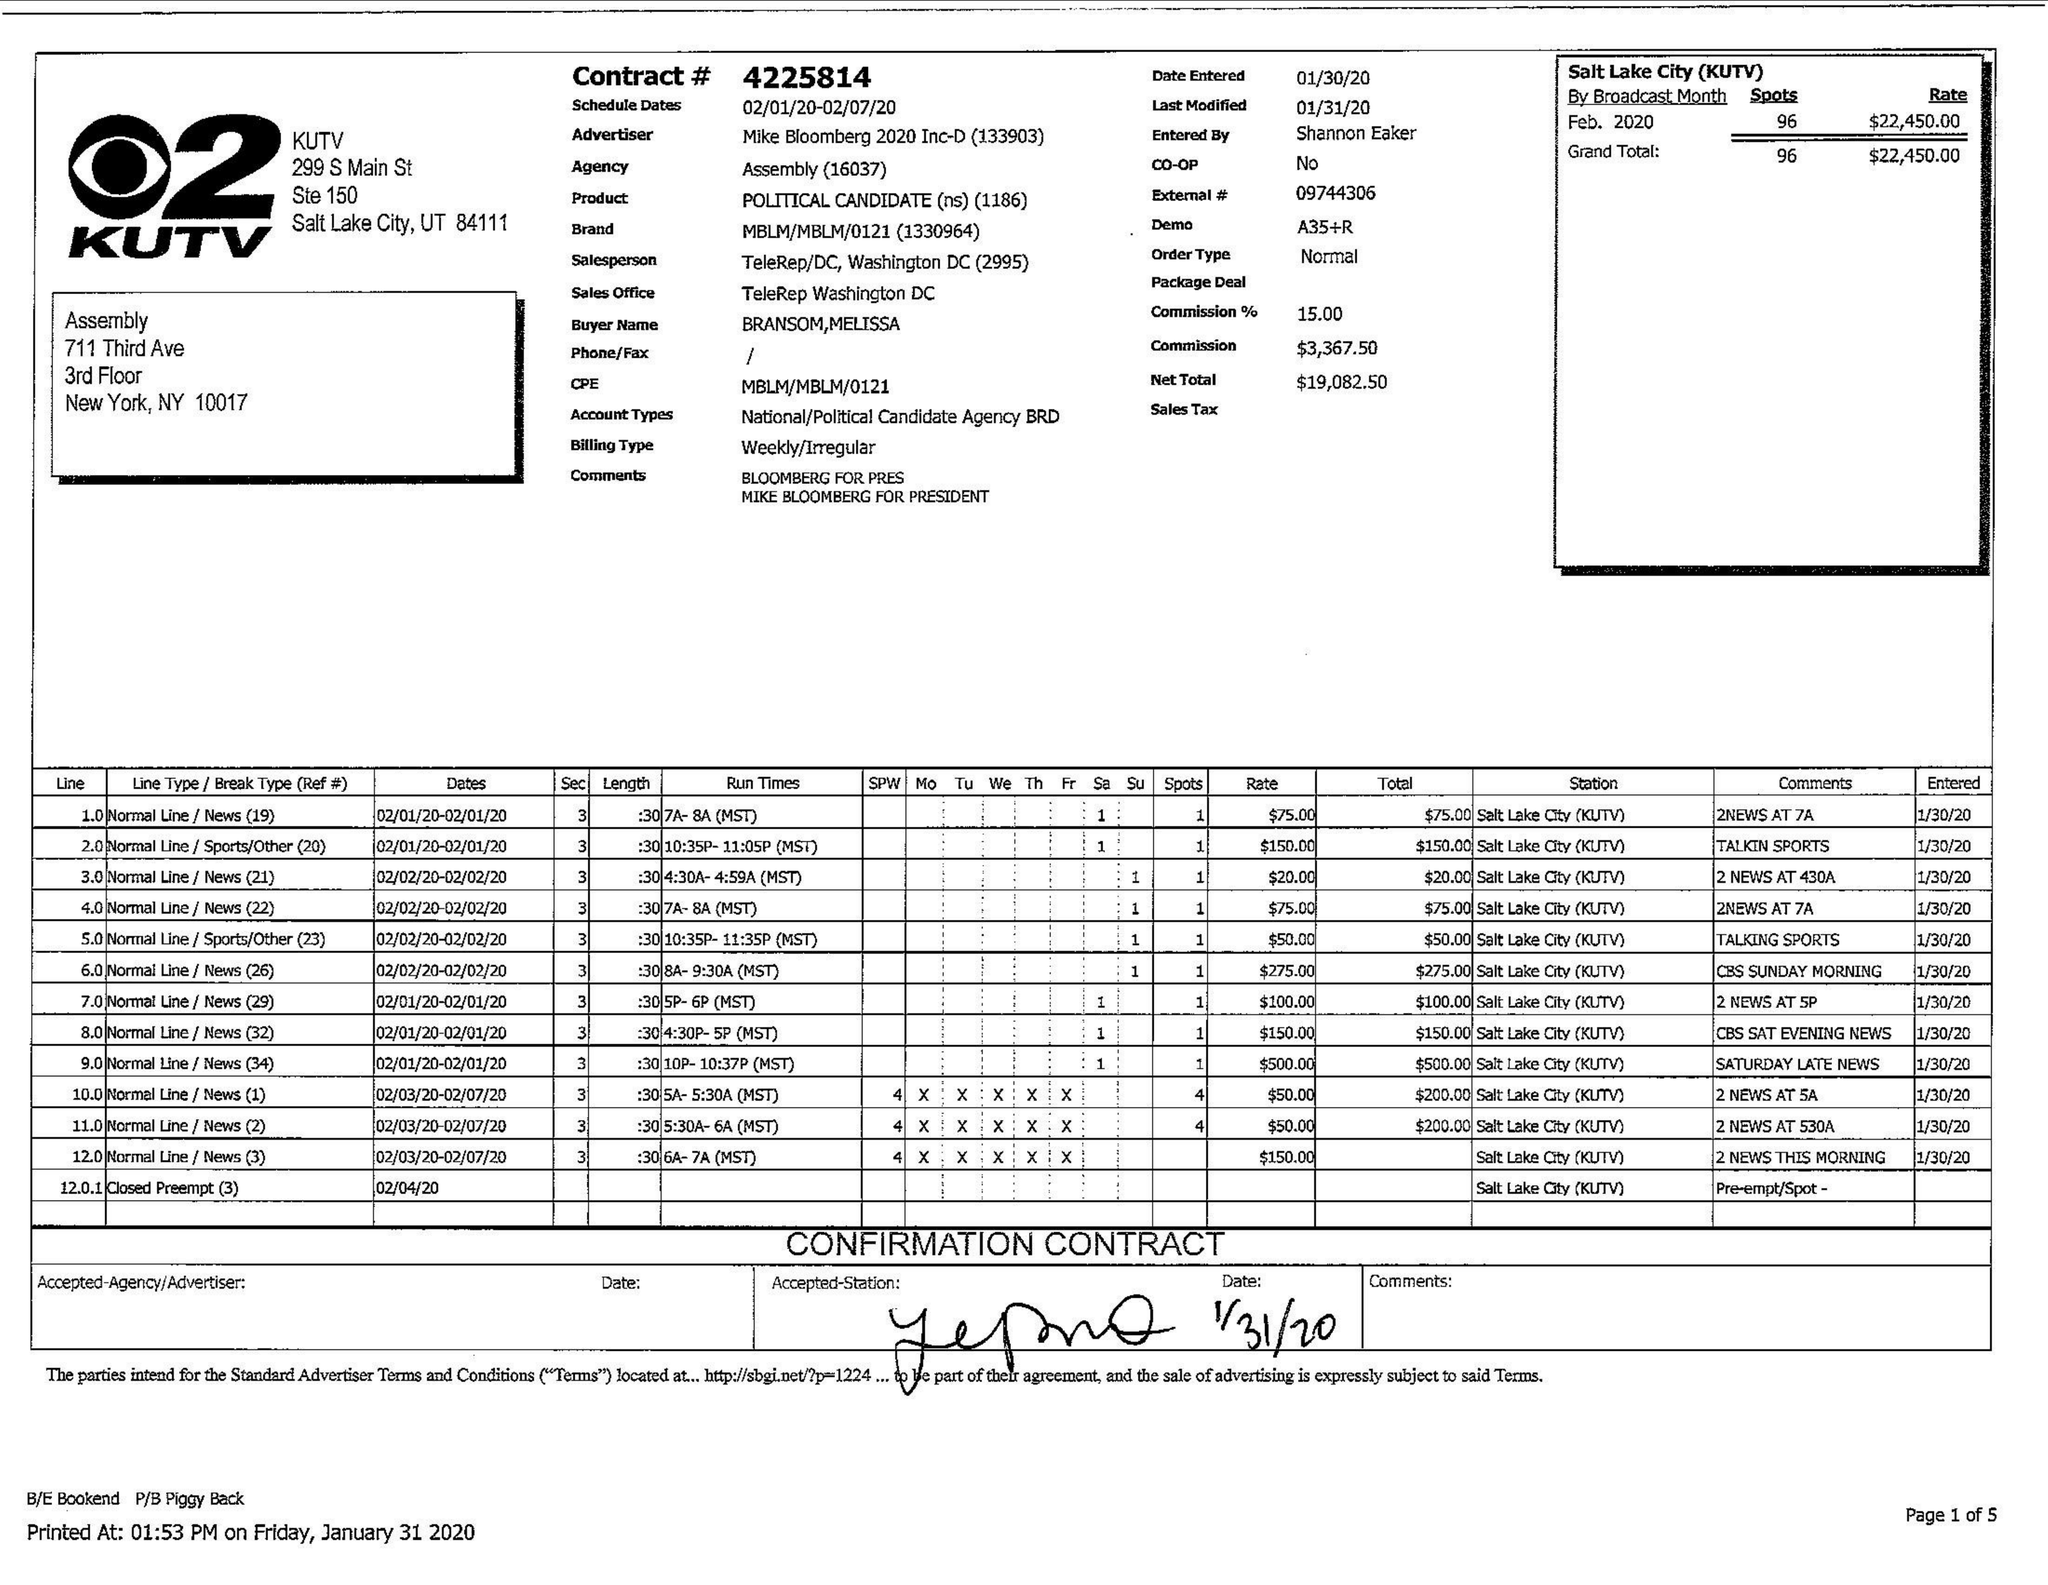What is the value for the advertiser?
Answer the question using a single word or phrase. MIKE BLOOMBERG 2020 INC-D 